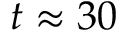Convert formula to latex. <formula><loc_0><loc_0><loc_500><loc_500>t \approx 3 0</formula> 